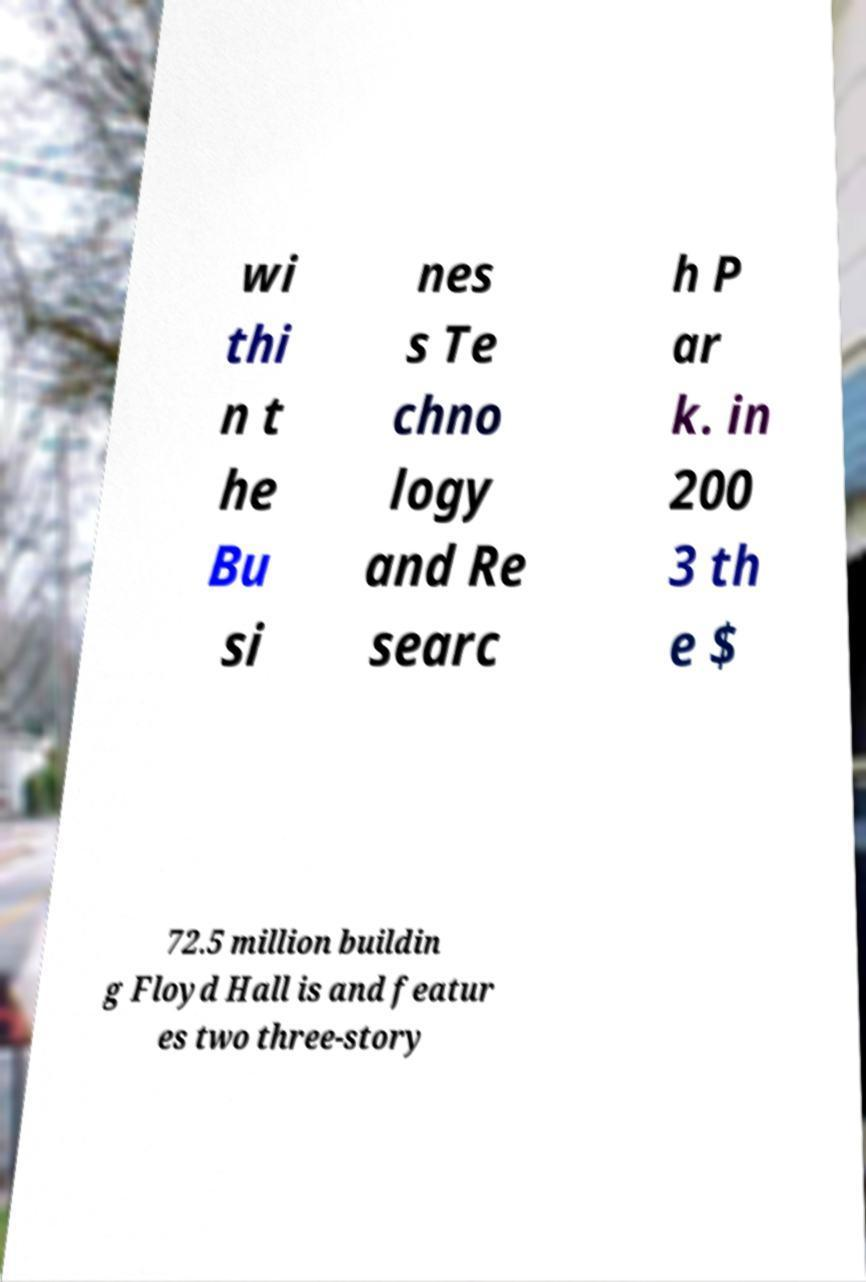For documentation purposes, I need the text within this image transcribed. Could you provide that? wi thi n t he Bu si nes s Te chno logy and Re searc h P ar k. in 200 3 th e $ 72.5 million buildin g Floyd Hall is and featur es two three-story 